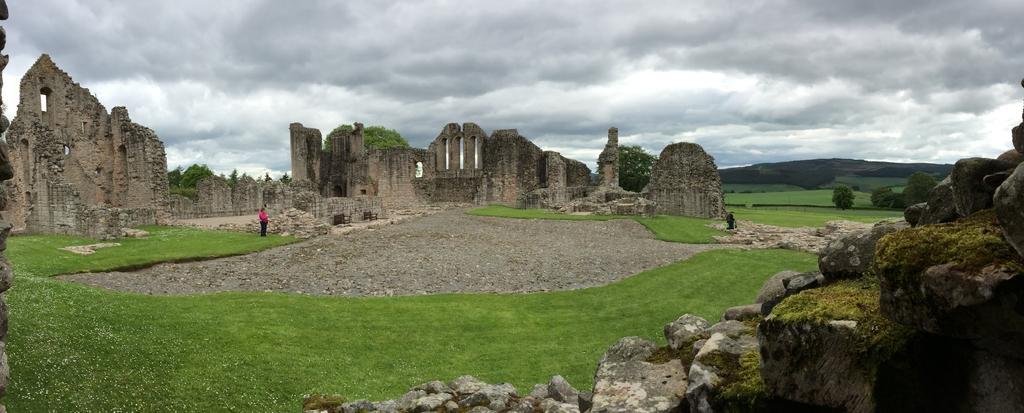Please provide a concise description of this image. In this picture, there are stone architectures in the center. At the bottom, there is grass and stones. Towards the left, there is a person. On the top, there is a sky with clouds. 